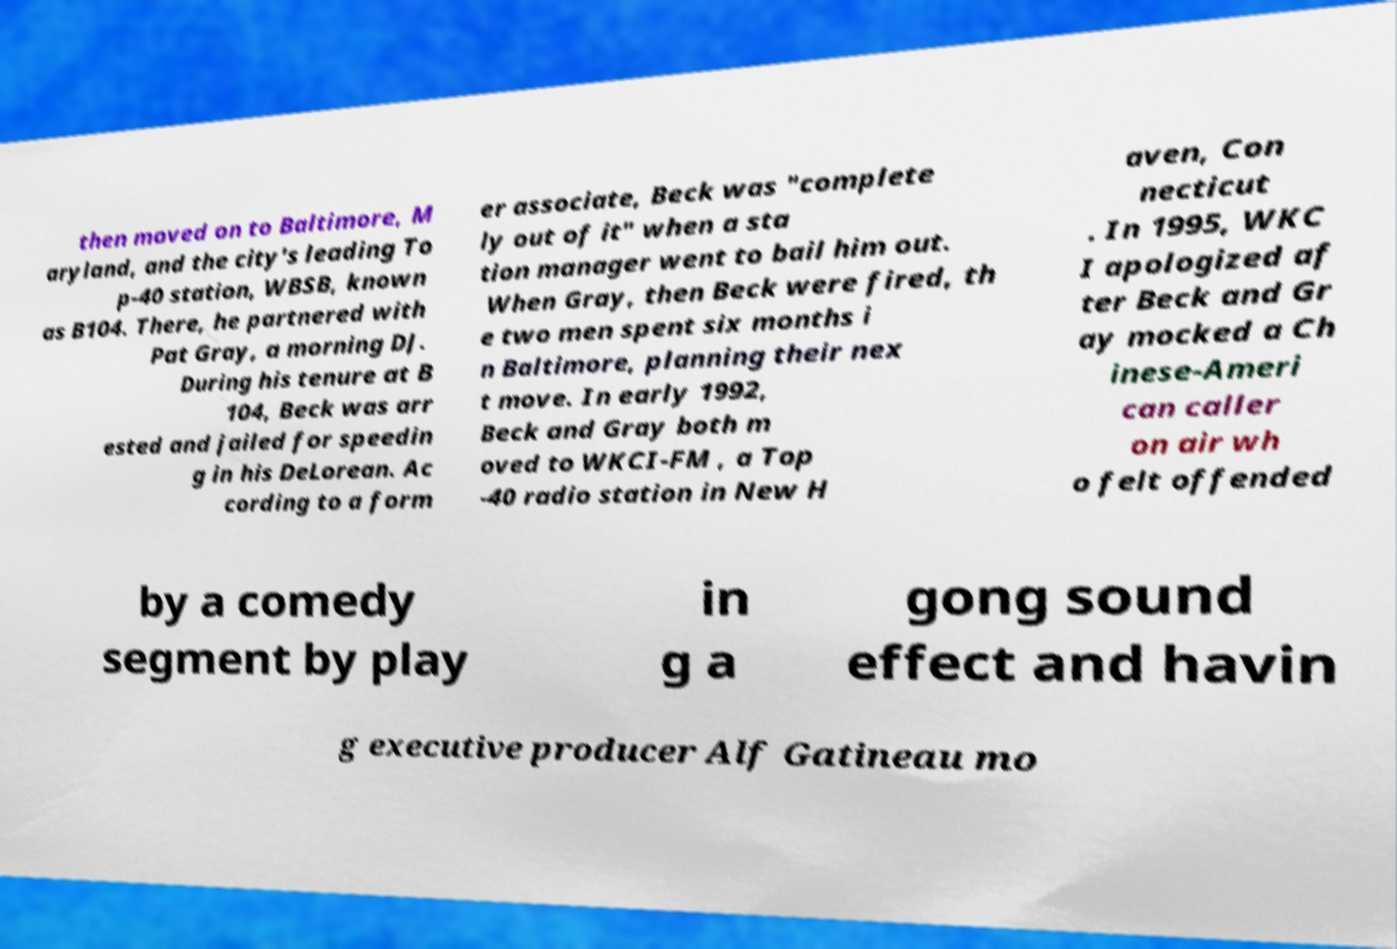Please read and relay the text visible in this image. What does it say? then moved on to Baltimore, M aryland, and the city's leading To p-40 station, WBSB, known as B104. There, he partnered with Pat Gray, a morning DJ. During his tenure at B 104, Beck was arr ested and jailed for speedin g in his DeLorean. Ac cording to a form er associate, Beck was "complete ly out of it" when a sta tion manager went to bail him out. When Gray, then Beck were fired, th e two men spent six months i n Baltimore, planning their nex t move. In early 1992, Beck and Gray both m oved to WKCI-FM , a Top -40 radio station in New H aven, Con necticut . In 1995, WKC I apologized af ter Beck and Gr ay mocked a Ch inese-Ameri can caller on air wh o felt offended by a comedy segment by play in g a gong sound effect and havin g executive producer Alf Gatineau mo 